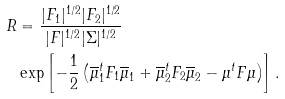<formula> <loc_0><loc_0><loc_500><loc_500>R & = \frac { | F _ { 1 } | ^ { 1 / 2 } | F _ { 2 } | ^ { 1 / 2 } } { | F | ^ { 1 / 2 } { | \Sigma | ^ { 1 / 2 } } } \\ & \exp \left [ - \frac { 1 } { 2 } \left ( \overline { \mu } _ { 1 } ^ { t } F _ { 1 } \overline { \mu } _ { 1 } + \overline { \mu } _ { 2 } ^ { t } F _ { 2 } \overline { \mu } _ { 2 } - \mu ^ { t } F \mu \right ) \right ] .</formula> 